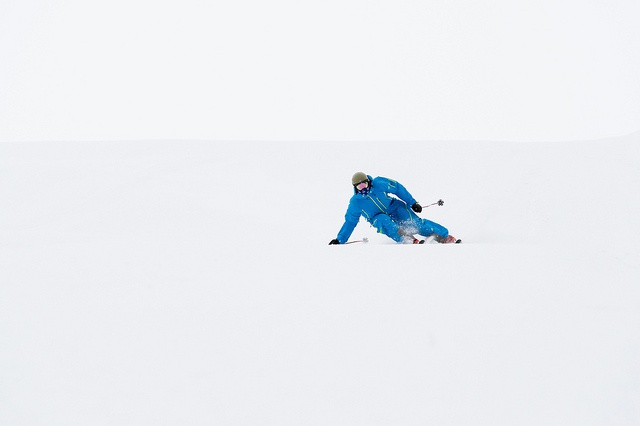Describe the objects in this image and their specific colors. I can see people in white, blue, gray, and navy tones and skis in white, black, and gray tones in this image. 